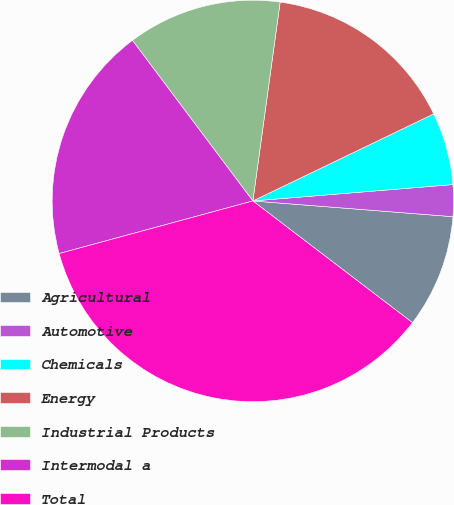Convert chart to OTSL. <chart><loc_0><loc_0><loc_500><loc_500><pie_chart><fcel>Agricultural<fcel>Automotive<fcel>Chemicals<fcel>Energy<fcel>Industrial Products<fcel>Intermodal a<fcel>Total<nl><fcel>9.12%<fcel>2.55%<fcel>5.84%<fcel>15.69%<fcel>12.41%<fcel>18.98%<fcel>35.41%<nl></chart> 